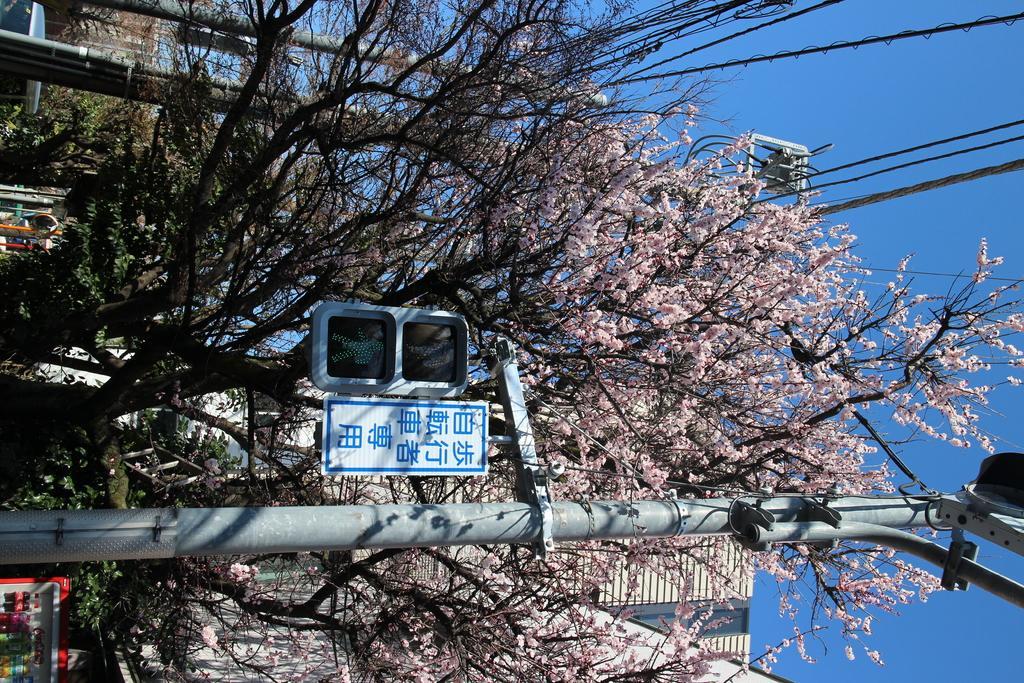Describe this image in one or two sentences. In this image I can see a light pole, trees, wires and buildings. On the right I can see the sky. This image is taken during a day. 